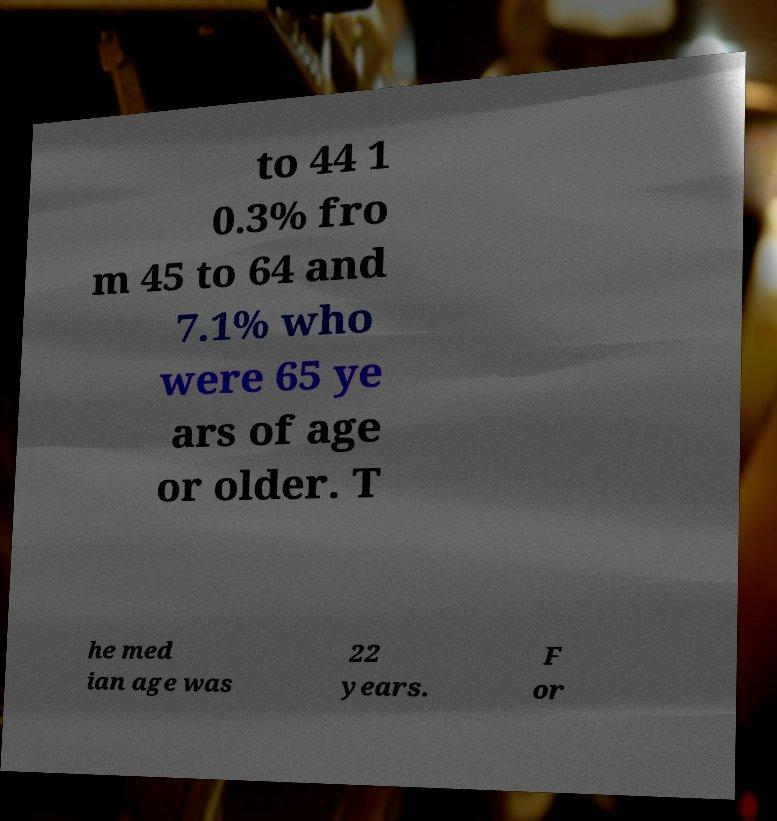Please read and relay the text visible in this image. What does it say? to 44 1 0.3% fro m 45 to 64 and 7.1% who were 65 ye ars of age or older. T he med ian age was 22 years. F or 